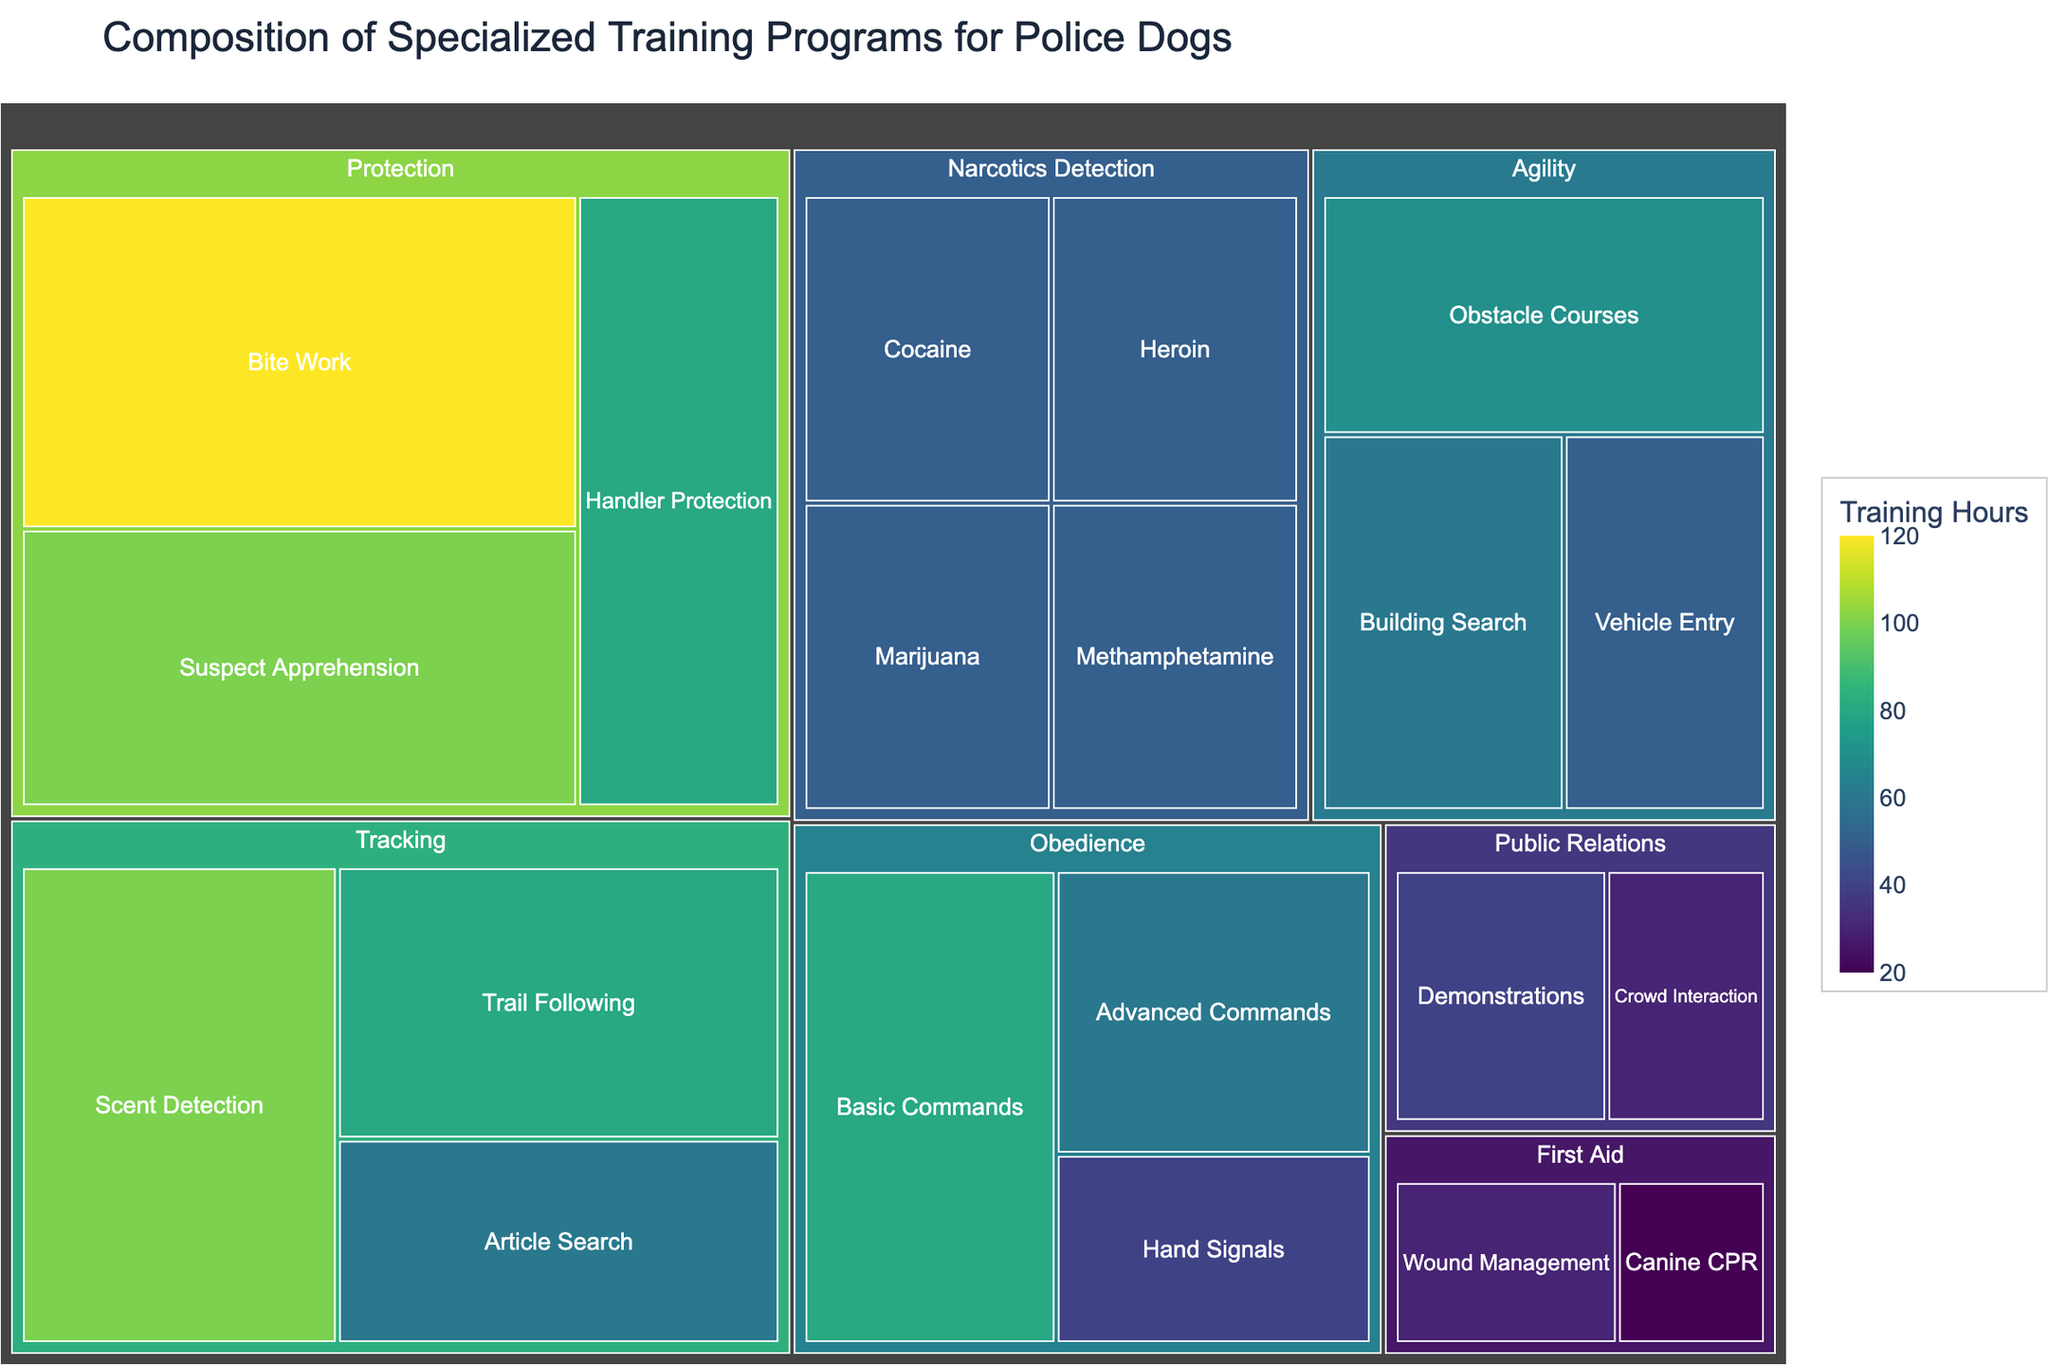What's the total number of training hours dedicated to Obedience training? To find the total hours for Obedience training, sum up the hours for each subcategory under Obedience: Basic Commands (80), Advanced Commands (60), and Hand Signals (40). 80 + 60 + 40 = 180.
Answer: 180 Which subcategory under Protection has the highest training hours? Under Protection, we have Bite Work (120), Suspect Apprehension (100), and Handler Protection (80). Bite Work has the highest training hours at 120.
Answer: Bite Work What is the least training time spent on any subcategory? Find the smallest value among all the subcategory training hours: Basic Commands (80), Advanced Commands (60), Hand Signals (40), Scent Detection (100), Trail Following (80), Article Search (60), Bite Work (120), Suspect Apprehension (100), Handler Protection (80), Marijuana (50), Cocaine (50), Heroin (50), Methamphetamine (50), Obstacle Courses (70), Building Search (60), Vehicle Entry (50), Crowd Interaction (30), Demonstrations (40), Canine CPR (20), Wound Management (30). The smallest is Canine CPR with 20.
Answer: Canine CPR How many subcategories are there in Narcotics Detection? Count the subcategories under Narcotics Detection: Marijuana, Cocaine, Heroin, and Methamphetamine. There are 4 subcategories.
Answer: 4 Which category has the most diverse range of subcategories? To determine this, count the number of subcategories in each category. Obedience has 3, Tracking has 3, Protection has 3, Narcotics Detection has 4, Agility has 3, Public Relations has 2, and First Aid has 2. Narcotics Detection has the most diverse range with 4 subcategories.
Answer: Narcotics Detection Is the time spent on Hand Signals greater than the time spent on Heroin detection? Compare the hours: Hand Signals (40) and Heroin detection (50). Hand Signals hours are less than Heroin detection hours.
Answer: No Which category has the highest total training hours? Sum the training hours for each category:
- Obedience: 80+60+40 = 180
- Tracking: 100+80+60 = 240
- Protection: 120+100+80 = 300
- Narcotics Detection: 50+50+50+50 = 200
- Agility: 70+60+50 = 180
- Public Relations: 30+40 = 70
- First Aid: 20+30 = 50
Protection has the highest total training hours with 300.
Answer: Protection 